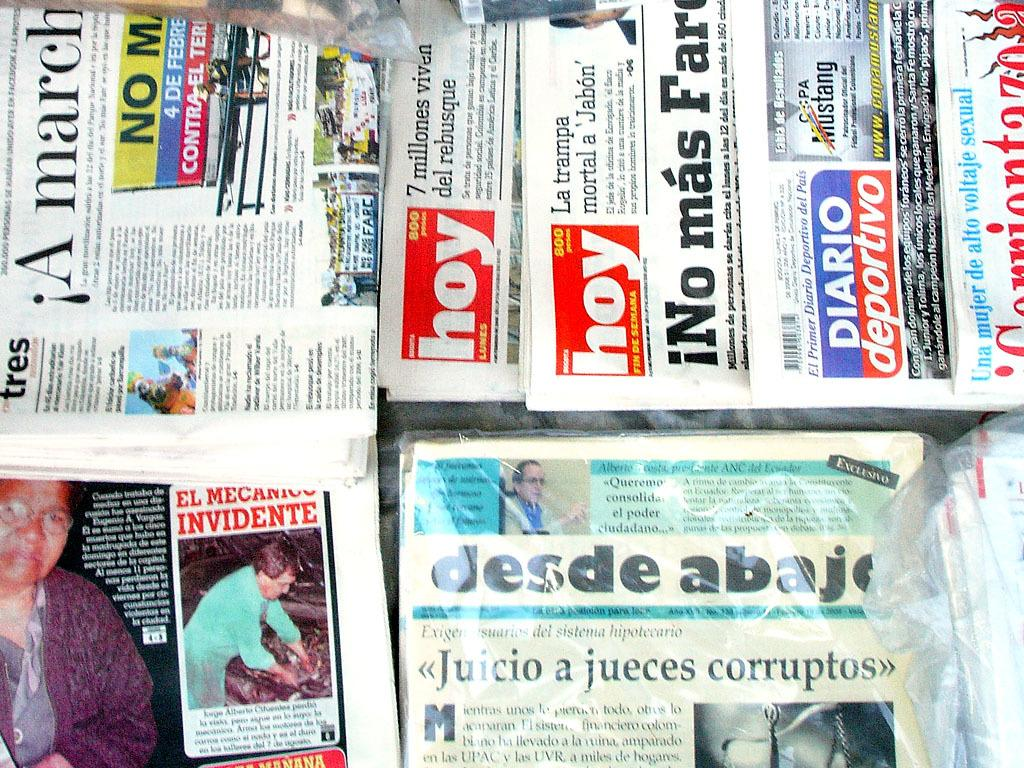<image>
Render a clear and concise summary of the photo. Several newspapers including hoy and desde abajo are stacked up on top of each other. 